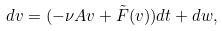<formula> <loc_0><loc_0><loc_500><loc_500>d v = ( - \nu A v + \tilde { F } ( v ) ) d t + d w ,</formula> 